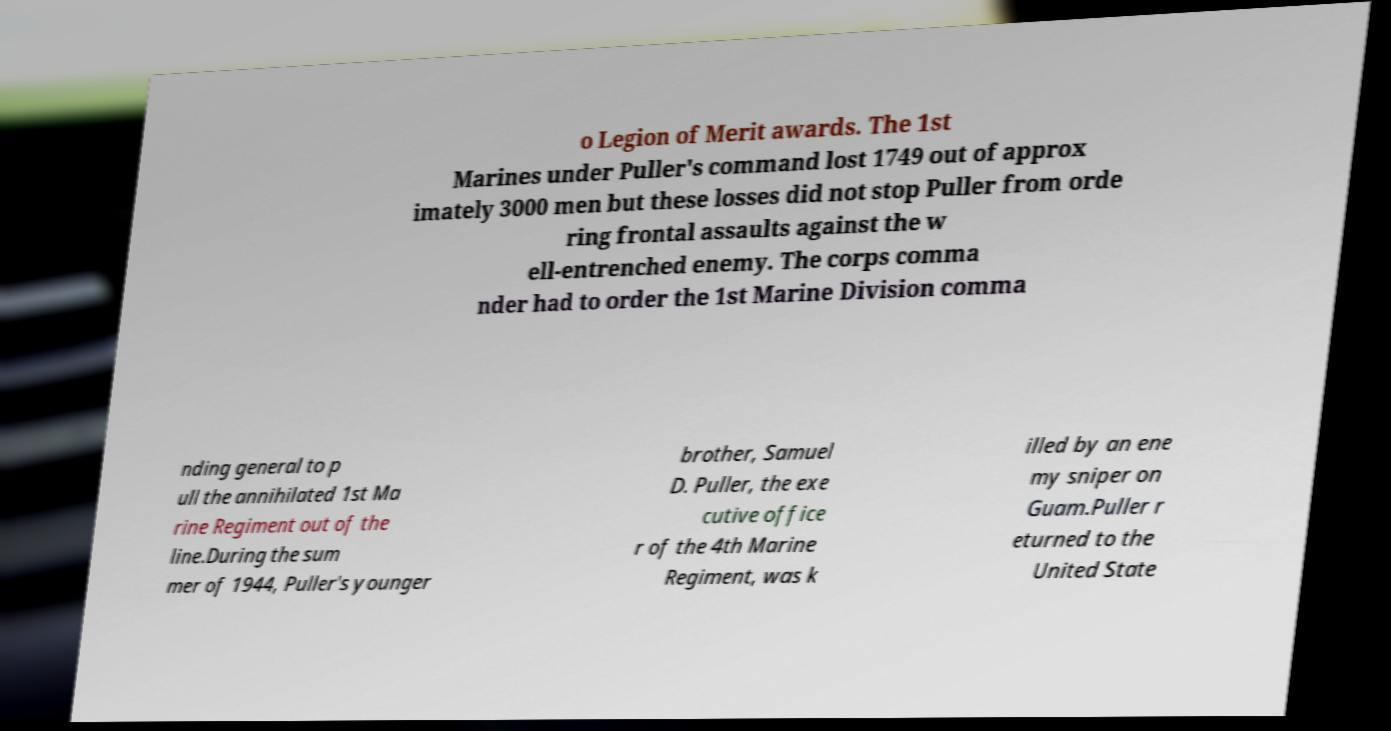Could you extract and type out the text from this image? o Legion of Merit awards. The 1st Marines under Puller's command lost 1749 out of approx imately 3000 men but these losses did not stop Puller from orde ring frontal assaults against the w ell-entrenched enemy. The corps comma nder had to order the 1st Marine Division comma nding general to p ull the annihilated 1st Ma rine Regiment out of the line.During the sum mer of 1944, Puller's younger brother, Samuel D. Puller, the exe cutive office r of the 4th Marine Regiment, was k illed by an ene my sniper on Guam.Puller r eturned to the United State 